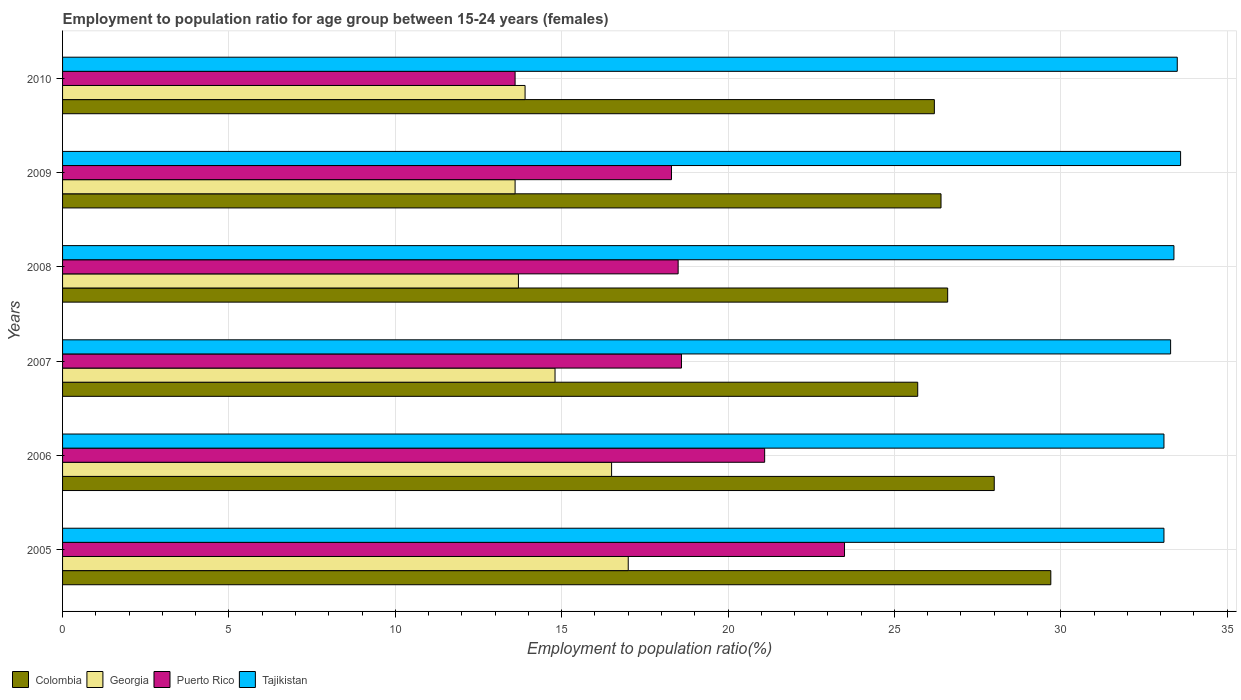How many different coloured bars are there?
Give a very brief answer. 4. How many bars are there on the 6th tick from the top?
Offer a very short reply. 4. How many bars are there on the 4th tick from the bottom?
Your answer should be compact. 4. What is the label of the 5th group of bars from the top?
Provide a short and direct response. 2006. In how many cases, is the number of bars for a given year not equal to the number of legend labels?
Provide a succinct answer. 0. What is the employment to population ratio in Georgia in 2006?
Ensure brevity in your answer.  16.5. Across all years, what is the maximum employment to population ratio in Tajikistan?
Provide a succinct answer. 33.6. Across all years, what is the minimum employment to population ratio in Tajikistan?
Provide a succinct answer. 33.1. In which year was the employment to population ratio in Colombia maximum?
Your answer should be very brief. 2005. In which year was the employment to population ratio in Colombia minimum?
Ensure brevity in your answer.  2007. What is the total employment to population ratio in Colombia in the graph?
Ensure brevity in your answer.  162.6. What is the difference between the employment to population ratio in Puerto Rico in 2009 and the employment to population ratio in Georgia in 2008?
Your answer should be very brief. 4.6. What is the average employment to population ratio in Puerto Rico per year?
Provide a succinct answer. 18.93. In the year 2007, what is the difference between the employment to population ratio in Puerto Rico and employment to population ratio in Georgia?
Offer a very short reply. 3.8. What is the ratio of the employment to population ratio in Georgia in 2006 to that in 2008?
Your answer should be compact. 1.2. Is the difference between the employment to population ratio in Puerto Rico in 2006 and 2008 greater than the difference between the employment to population ratio in Georgia in 2006 and 2008?
Your answer should be compact. No. What is the difference between the highest and the second highest employment to population ratio in Colombia?
Offer a very short reply. 1.7. Is the sum of the employment to population ratio in Puerto Rico in 2007 and 2008 greater than the maximum employment to population ratio in Colombia across all years?
Keep it short and to the point. Yes. Is it the case that in every year, the sum of the employment to population ratio in Tajikistan and employment to population ratio in Colombia is greater than the sum of employment to population ratio in Georgia and employment to population ratio in Puerto Rico?
Provide a succinct answer. Yes. What does the 2nd bar from the bottom in 2005 represents?
Ensure brevity in your answer.  Georgia. How many bars are there?
Your answer should be very brief. 24. Are all the bars in the graph horizontal?
Offer a very short reply. Yes. Where does the legend appear in the graph?
Offer a very short reply. Bottom left. How are the legend labels stacked?
Your response must be concise. Horizontal. What is the title of the graph?
Make the answer very short. Employment to population ratio for age group between 15-24 years (females). What is the label or title of the Y-axis?
Keep it short and to the point. Years. What is the Employment to population ratio(%) of Colombia in 2005?
Provide a short and direct response. 29.7. What is the Employment to population ratio(%) in Puerto Rico in 2005?
Provide a short and direct response. 23.5. What is the Employment to population ratio(%) in Tajikistan in 2005?
Provide a succinct answer. 33.1. What is the Employment to population ratio(%) in Georgia in 2006?
Ensure brevity in your answer.  16.5. What is the Employment to population ratio(%) of Puerto Rico in 2006?
Make the answer very short. 21.1. What is the Employment to population ratio(%) in Tajikistan in 2006?
Keep it short and to the point. 33.1. What is the Employment to population ratio(%) in Colombia in 2007?
Your response must be concise. 25.7. What is the Employment to population ratio(%) of Georgia in 2007?
Your response must be concise. 14.8. What is the Employment to population ratio(%) in Puerto Rico in 2007?
Make the answer very short. 18.6. What is the Employment to population ratio(%) of Tajikistan in 2007?
Keep it short and to the point. 33.3. What is the Employment to population ratio(%) in Colombia in 2008?
Your answer should be very brief. 26.6. What is the Employment to population ratio(%) of Georgia in 2008?
Make the answer very short. 13.7. What is the Employment to population ratio(%) in Tajikistan in 2008?
Provide a short and direct response. 33.4. What is the Employment to population ratio(%) of Colombia in 2009?
Offer a terse response. 26.4. What is the Employment to population ratio(%) of Georgia in 2009?
Ensure brevity in your answer.  13.6. What is the Employment to population ratio(%) of Puerto Rico in 2009?
Give a very brief answer. 18.3. What is the Employment to population ratio(%) in Tajikistan in 2009?
Your answer should be compact. 33.6. What is the Employment to population ratio(%) in Colombia in 2010?
Provide a short and direct response. 26.2. What is the Employment to population ratio(%) of Georgia in 2010?
Your answer should be compact. 13.9. What is the Employment to population ratio(%) of Puerto Rico in 2010?
Offer a terse response. 13.6. What is the Employment to population ratio(%) of Tajikistan in 2010?
Your answer should be very brief. 33.5. Across all years, what is the maximum Employment to population ratio(%) of Colombia?
Give a very brief answer. 29.7. Across all years, what is the maximum Employment to population ratio(%) of Georgia?
Offer a terse response. 17. Across all years, what is the maximum Employment to population ratio(%) in Tajikistan?
Your answer should be very brief. 33.6. Across all years, what is the minimum Employment to population ratio(%) of Colombia?
Provide a succinct answer. 25.7. Across all years, what is the minimum Employment to population ratio(%) of Georgia?
Offer a terse response. 13.6. Across all years, what is the minimum Employment to population ratio(%) in Puerto Rico?
Provide a succinct answer. 13.6. Across all years, what is the minimum Employment to population ratio(%) of Tajikistan?
Offer a terse response. 33.1. What is the total Employment to population ratio(%) in Colombia in the graph?
Your answer should be very brief. 162.6. What is the total Employment to population ratio(%) in Georgia in the graph?
Your answer should be compact. 89.5. What is the total Employment to population ratio(%) in Puerto Rico in the graph?
Your answer should be very brief. 113.6. What is the difference between the Employment to population ratio(%) of Georgia in 2005 and that in 2006?
Make the answer very short. 0.5. What is the difference between the Employment to population ratio(%) in Puerto Rico in 2005 and that in 2007?
Provide a succinct answer. 4.9. What is the difference between the Employment to population ratio(%) in Colombia in 2005 and that in 2008?
Your answer should be compact. 3.1. What is the difference between the Employment to population ratio(%) in Colombia in 2005 and that in 2009?
Provide a short and direct response. 3.3. What is the difference between the Employment to population ratio(%) in Puerto Rico in 2005 and that in 2009?
Your answer should be compact. 5.2. What is the difference between the Employment to population ratio(%) in Tajikistan in 2005 and that in 2009?
Offer a very short reply. -0.5. What is the difference between the Employment to population ratio(%) in Georgia in 2005 and that in 2010?
Provide a short and direct response. 3.1. What is the difference between the Employment to population ratio(%) in Tajikistan in 2005 and that in 2010?
Provide a short and direct response. -0.4. What is the difference between the Employment to population ratio(%) in Georgia in 2006 and that in 2007?
Your answer should be compact. 1.7. What is the difference between the Employment to population ratio(%) in Tajikistan in 2006 and that in 2007?
Give a very brief answer. -0.2. What is the difference between the Employment to population ratio(%) in Puerto Rico in 2006 and that in 2008?
Provide a succinct answer. 2.6. What is the difference between the Employment to population ratio(%) in Tajikistan in 2006 and that in 2008?
Offer a terse response. -0.3. What is the difference between the Employment to population ratio(%) of Colombia in 2006 and that in 2009?
Keep it short and to the point. 1.6. What is the difference between the Employment to population ratio(%) in Georgia in 2006 and that in 2009?
Make the answer very short. 2.9. What is the difference between the Employment to population ratio(%) in Puerto Rico in 2006 and that in 2009?
Provide a succinct answer. 2.8. What is the difference between the Employment to population ratio(%) of Tajikistan in 2006 and that in 2009?
Give a very brief answer. -0.5. What is the difference between the Employment to population ratio(%) of Colombia in 2006 and that in 2010?
Make the answer very short. 1.8. What is the difference between the Employment to population ratio(%) of Puerto Rico in 2006 and that in 2010?
Your answer should be very brief. 7.5. What is the difference between the Employment to population ratio(%) in Tajikistan in 2006 and that in 2010?
Offer a very short reply. -0.4. What is the difference between the Employment to population ratio(%) in Georgia in 2007 and that in 2008?
Your response must be concise. 1.1. What is the difference between the Employment to population ratio(%) of Tajikistan in 2007 and that in 2008?
Your answer should be compact. -0.1. What is the difference between the Employment to population ratio(%) of Colombia in 2007 and that in 2010?
Provide a succinct answer. -0.5. What is the difference between the Employment to population ratio(%) in Tajikistan in 2007 and that in 2010?
Provide a short and direct response. -0.2. What is the difference between the Employment to population ratio(%) in Puerto Rico in 2008 and that in 2009?
Ensure brevity in your answer.  0.2. What is the difference between the Employment to population ratio(%) of Tajikistan in 2008 and that in 2009?
Make the answer very short. -0.2. What is the difference between the Employment to population ratio(%) in Georgia in 2008 and that in 2010?
Make the answer very short. -0.2. What is the difference between the Employment to population ratio(%) in Puerto Rico in 2008 and that in 2010?
Your answer should be very brief. 4.9. What is the difference between the Employment to population ratio(%) of Tajikistan in 2008 and that in 2010?
Offer a very short reply. -0.1. What is the difference between the Employment to population ratio(%) of Georgia in 2009 and that in 2010?
Keep it short and to the point. -0.3. What is the difference between the Employment to population ratio(%) in Tajikistan in 2009 and that in 2010?
Your response must be concise. 0.1. What is the difference between the Employment to population ratio(%) of Colombia in 2005 and the Employment to population ratio(%) of Georgia in 2006?
Offer a very short reply. 13.2. What is the difference between the Employment to population ratio(%) in Colombia in 2005 and the Employment to population ratio(%) in Puerto Rico in 2006?
Ensure brevity in your answer.  8.6. What is the difference between the Employment to population ratio(%) in Georgia in 2005 and the Employment to population ratio(%) in Puerto Rico in 2006?
Keep it short and to the point. -4.1. What is the difference between the Employment to population ratio(%) of Georgia in 2005 and the Employment to population ratio(%) of Tajikistan in 2006?
Your answer should be very brief. -16.1. What is the difference between the Employment to population ratio(%) of Colombia in 2005 and the Employment to population ratio(%) of Puerto Rico in 2007?
Ensure brevity in your answer.  11.1. What is the difference between the Employment to population ratio(%) of Georgia in 2005 and the Employment to population ratio(%) of Puerto Rico in 2007?
Offer a very short reply. -1.6. What is the difference between the Employment to population ratio(%) of Georgia in 2005 and the Employment to population ratio(%) of Tajikistan in 2007?
Your answer should be very brief. -16.3. What is the difference between the Employment to population ratio(%) in Georgia in 2005 and the Employment to population ratio(%) in Puerto Rico in 2008?
Give a very brief answer. -1.5. What is the difference between the Employment to population ratio(%) of Georgia in 2005 and the Employment to population ratio(%) of Tajikistan in 2008?
Ensure brevity in your answer.  -16.4. What is the difference between the Employment to population ratio(%) of Puerto Rico in 2005 and the Employment to population ratio(%) of Tajikistan in 2008?
Keep it short and to the point. -9.9. What is the difference between the Employment to population ratio(%) in Colombia in 2005 and the Employment to population ratio(%) in Puerto Rico in 2009?
Keep it short and to the point. 11.4. What is the difference between the Employment to population ratio(%) in Georgia in 2005 and the Employment to population ratio(%) in Tajikistan in 2009?
Make the answer very short. -16.6. What is the difference between the Employment to population ratio(%) of Colombia in 2005 and the Employment to population ratio(%) of Georgia in 2010?
Offer a terse response. 15.8. What is the difference between the Employment to population ratio(%) of Colombia in 2005 and the Employment to population ratio(%) of Puerto Rico in 2010?
Your response must be concise. 16.1. What is the difference between the Employment to population ratio(%) of Georgia in 2005 and the Employment to population ratio(%) of Tajikistan in 2010?
Make the answer very short. -16.5. What is the difference between the Employment to population ratio(%) in Puerto Rico in 2005 and the Employment to population ratio(%) in Tajikistan in 2010?
Your response must be concise. -10. What is the difference between the Employment to population ratio(%) of Colombia in 2006 and the Employment to population ratio(%) of Georgia in 2007?
Ensure brevity in your answer.  13.2. What is the difference between the Employment to population ratio(%) of Colombia in 2006 and the Employment to population ratio(%) of Tajikistan in 2007?
Give a very brief answer. -5.3. What is the difference between the Employment to population ratio(%) in Georgia in 2006 and the Employment to population ratio(%) in Puerto Rico in 2007?
Your answer should be compact. -2.1. What is the difference between the Employment to population ratio(%) of Georgia in 2006 and the Employment to population ratio(%) of Tajikistan in 2007?
Your answer should be compact. -16.8. What is the difference between the Employment to population ratio(%) in Colombia in 2006 and the Employment to population ratio(%) in Georgia in 2008?
Your answer should be very brief. 14.3. What is the difference between the Employment to population ratio(%) in Georgia in 2006 and the Employment to population ratio(%) in Tajikistan in 2008?
Offer a terse response. -16.9. What is the difference between the Employment to population ratio(%) in Puerto Rico in 2006 and the Employment to population ratio(%) in Tajikistan in 2008?
Ensure brevity in your answer.  -12.3. What is the difference between the Employment to population ratio(%) of Colombia in 2006 and the Employment to population ratio(%) of Georgia in 2009?
Keep it short and to the point. 14.4. What is the difference between the Employment to population ratio(%) of Georgia in 2006 and the Employment to population ratio(%) of Tajikistan in 2009?
Keep it short and to the point. -17.1. What is the difference between the Employment to population ratio(%) of Puerto Rico in 2006 and the Employment to population ratio(%) of Tajikistan in 2009?
Provide a short and direct response. -12.5. What is the difference between the Employment to population ratio(%) of Colombia in 2006 and the Employment to population ratio(%) of Puerto Rico in 2010?
Your response must be concise. 14.4. What is the difference between the Employment to population ratio(%) in Georgia in 2006 and the Employment to population ratio(%) in Puerto Rico in 2010?
Your answer should be very brief. 2.9. What is the difference between the Employment to population ratio(%) in Colombia in 2007 and the Employment to population ratio(%) in Georgia in 2008?
Ensure brevity in your answer.  12. What is the difference between the Employment to population ratio(%) of Georgia in 2007 and the Employment to population ratio(%) of Puerto Rico in 2008?
Keep it short and to the point. -3.7. What is the difference between the Employment to population ratio(%) of Georgia in 2007 and the Employment to population ratio(%) of Tajikistan in 2008?
Your answer should be very brief. -18.6. What is the difference between the Employment to population ratio(%) of Puerto Rico in 2007 and the Employment to population ratio(%) of Tajikistan in 2008?
Keep it short and to the point. -14.8. What is the difference between the Employment to population ratio(%) of Colombia in 2007 and the Employment to population ratio(%) of Georgia in 2009?
Provide a short and direct response. 12.1. What is the difference between the Employment to population ratio(%) in Colombia in 2007 and the Employment to population ratio(%) in Tajikistan in 2009?
Your response must be concise. -7.9. What is the difference between the Employment to population ratio(%) in Georgia in 2007 and the Employment to population ratio(%) in Puerto Rico in 2009?
Offer a terse response. -3.5. What is the difference between the Employment to population ratio(%) of Georgia in 2007 and the Employment to population ratio(%) of Tajikistan in 2009?
Give a very brief answer. -18.8. What is the difference between the Employment to population ratio(%) of Colombia in 2007 and the Employment to population ratio(%) of Georgia in 2010?
Your answer should be very brief. 11.8. What is the difference between the Employment to population ratio(%) in Georgia in 2007 and the Employment to population ratio(%) in Tajikistan in 2010?
Keep it short and to the point. -18.7. What is the difference between the Employment to population ratio(%) of Puerto Rico in 2007 and the Employment to population ratio(%) of Tajikistan in 2010?
Provide a short and direct response. -14.9. What is the difference between the Employment to population ratio(%) in Colombia in 2008 and the Employment to population ratio(%) in Georgia in 2009?
Your answer should be compact. 13. What is the difference between the Employment to population ratio(%) in Colombia in 2008 and the Employment to population ratio(%) in Puerto Rico in 2009?
Your response must be concise. 8.3. What is the difference between the Employment to population ratio(%) in Georgia in 2008 and the Employment to population ratio(%) in Tajikistan in 2009?
Make the answer very short. -19.9. What is the difference between the Employment to population ratio(%) in Puerto Rico in 2008 and the Employment to population ratio(%) in Tajikistan in 2009?
Give a very brief answer. -15.1. What is the difference between the Employment to population ratio(%) in Colombia in 2008 and the Employment to population ratio(%) in Tajikistan in 2010?
Offer a terse response. -6.9. What is the difference between the Employment to population ratio(%) of Georgia in 2008 and the Employment to population ratio(%) of Tajikistan in 2010?
Provide a succinct answer. -19.8. What is the difference between the Employment to population ratio(%) in Puerto Rico in 2008 and the Employment to population ratio(%) in Tajikistan in 2010?
Provide a succinct answer. -15. What is the difference between the Employment to population ratio(%) of Colombia in 2009 and the Employment to population ratio(%) of Georgia in 2010?
Make the answer very short. 12.5. What is the difference between the Employment to population ratio(%) of Colombia in 2009 and the Employment to population ratio(%) of Tajikistan in 2010?
Ensure brevity in your answer.  -7.1. What is the difference between the Employment to population ratio(%) in Georgia in 2009 and the Employment to population ratio(%) in Tajikistan in 2010?
Your response must be concise. -19.9. What is the difference between the Employment to population ratio(%) in Puerto Rico in 2009 and the Employment to population ratio(%) in Tajikistan in 2010?
Your answer should be very brief. -15.2. What is the average Employment to population ratio(%) in Colombia per year?
Give a very brief answer. 27.1. What is the average Employment to population ratio(%) in Georgia per year?
Your answer should be very brief. 14.92. What is the average Employment to population ratio(%) in Puerto Rico per year?
Provide a short and direct response. 18.93. What is the average Employment to population ratio(%) of Tajikistan per year?
Offer a terse response. 33.33. In the year 2005, what is the difference between the Employment to population ratio(%) of Colombia and Employment to population ratio(%) of Puerto Rico?
Your response must be concise. 6.2. In the year 2005, what is the difference between the Employment to population ratio(%) in Colombia and Employment to population ratio(%) in Tajikistan?
Offer a very short reply. -3.4. In the year 2005, what is the difference between the Employment to population ratio(%) in Georgia and Employment to population ratio(%) in Puerto Rico?
Your answer should be compact. -6.5. In the year 2005, what is the difference between the Employment to population ratio(%) in Georgia and Employment to population ratio(%) in Tajikistan?
Ensure brevity in your answer.  -16.1. In the year 2006, what is the difference between the Employment to population ratio(%) of Colombia and Employment to population ratio(%) of Puerto Rico?
Ensure brevity in your answer.  6.9. In the year 2006, what is the difference between the Employment to population ratio(%) of Colombia and Employment to population ratio(%) of Tajikistan?
Your answer should be very brief. -5.1. In the year 2006, what is the difference between the Employment to population ratio(%) in Georgia and Employment to population ratio(%) in Tajikistan?
Provide a short and direct response. -16.6. In the year 2007, what is the difference between the Employment to population ratio(%) of Colombia and Employment to population ratio(%) of Puerto Rico?
Your answer should be compact. 7.1. In the year 2007, what is the difference between the Employment to population ratio(%) of Colombia and Employment to population ratio(%) of Tajikistan?
Ensure brevity in your answer.  -7.6. In the year 2007, what is the difference between the Employment to population ratio(%) of Georgia and Employment to population ratio(%) of Puerto Rico?
Provide a short and direct response. -3.8. In the year 2007, what is the difference between the Employment to population ratio(%) of Georgia and Employment to population ratio(%) of Tajikistan?
Give a very brief answer. -18.5. In the year 2007, what is the difference between the Employment to population ratio(%) in Puerto Rico and Employment to population ratio(%) in Tajikistan?
Your response must be concise. -14.7. In the year 2008, what is the difference between the Employment to population ratio(%) of Colombia and Employment to population ratio(%) of Puerto Rico?
Offer a very short reply. 8.1. In the year 2008, what is the difference between the Employment to population ratio(%) in Colombia and Employment to population ratio(%) in Tajikistan?
Make the answer very short. -6.8. In the year 2008, what is the difference between the Employment to population ratio(%) in Georgia and Employment to population ratio(%) in Tajikistan?
Your answer should be very brief. -19.7. In the year 2008, what is the difference between the Employment to population ratio(%) of Puerto Rico and Employment to population ratio(%) of Tajikistan?
Provide a succinct answer. -14.9. In the year 2009, what is the difference between the Employment to population ratio(%) of Colombia and Employment to population ratio(%) of Puerto Rico?
Keep it short and to the point. 8.1. In the year 2009, what is the difference between the Employment to population ratio(%) in Georgia and Employment to population ratio(%) in Puerto Rico?
Ensure brevity in your answer.  -4.7. In the year 2009, what is the difference between the Employment to population ratio(%) of Puerto Rico and Employment to population ratio(%) of Tajikistan?
Your answer should be very brief. -15.3. In the year 2010, what is the difference between the Employment to population ratio(%) of Colombia and Employment to population ratio(%) of Georgia?
Your answer should be very brief. 12.3. In the year 2010, what is the difference between the Employment to population ratio(%) in Georgia and Employment to population ratio(%) in Tajikistan?
Offer a very short reply. -19.6. In the year 2010, what is the difference between the Employment to population ratio(%) of Puerto Rico and Employment to population ratio(%) of Tajikistan?
Offer a terse response. -19.9. What is the ratio of the Employment to population ratio(%) in Colombia in 2005 to that in 2006?
Provide a short and direct response. 1.06. What is the ratio of the Employment to population ratio(%) of Georgia in 2005 to that in 2006?
Provide a succinct answer. 1.03. What is the ratio of the Employment to population ratio(%) of Puerto Rico in 2005 to that in 2006?
Keep it short and to the point. 1.11. What is the ratio of the Employment to population ratio(%) in Tajikistan in 2005 to that in 2006?
Your response must be concise. 1. What is the ratio of the Employment to population ratio(%) of Colombia in 2005 to that in 2007?
Keep it short and to the point. 1.16. What is the ratio of the Employment to population ratio(%) in Georgia in 2005 to that in 2007?
Your answer should be compact. 1.15. What is the ratio of the Employment to population ratio(%) of Puerto Rico in 2005 to that in 2007?
Offer a very short reply. 1.26. What is the ratio of the Employment to population ratio(%) of Tajikistan in 2005 to that in 2007?
Your response must be concise. 0.99. What is the ratio of the Employment to population ratio(%) of Colombia in 2005 to that in 2008?
Your answer should be very brief. 1.12. What is the ratio of the Employment to population ratio(%) of Georgia in 2005 to that in 2008?
Make the answer very short. 1.24. What is the ratio of the Employment to population ratio(%) of Puerto Rico in 2005 to that in 2008?
Your answer should be compact. 1.27. What is the ratio of the Employment to population ratio(%) of Tajikistan in 2005 to that in 2008?
Provide a short and direct response. 0.99. What is the ratio of the Employment to population ratio(%) of Puerto Rico in 2005 to that in 2009?
Offer a very short reply. 1.28. What is the ratio of the Employment to population ratio(%) of Tajikistan in 2005 to that in 2009?
Your answer should be very brief. 0.99. What is the ratio of the Employment to population ratio(%) in Colombia in 2005 to that in 2010?
Your answer should be very brief. 1.13. What is the ratio of the Employment to population ratio(%) in Georgia in 2005 to that in 2010?
Offer a very short reply. 1.22. What is the ratio of the Employment to population ratio(%) in Puerto Rico in 2005 to that in 2010?
Offer a very short reply. 1.73. What is the ratio of the Employment to population ratio(%) in Colombia in 2006 to that in 2007?
Keep it short and to the point. 1.09. What is the ratio of the Employment to population ratio(%) of Georgia in 2006 to that in 2007?
Give a very brief answer. 1.11. What is the ratio of the Employment to population ratio(%) of Puerto Rico in 2006 to that in 2007?
Offer a terse response. 1.13. What is the ratio of the Employment to population ratio(%) in Tajikistan in 2006 to that in 2007?
Ensure brevity in your answer.  0.99. What is the ratio of the Employment to population ratio(%) in Colombia in 2006 to that in 2008?
Ensure brevity in your answer.  1.05. What is the ratio of the Employment to population ratio(%) of Georgia in 2006 to that in 2008?
Offer a very short reply. 1.2. What is the ratio of the Employment to population ratio(%) of Puerto Rico in 2006 to that in 2008?
Your response must be concise. 1.14. What is the ratio of the Employment to population ratio(%) in Colombia in 2006 to that in 2009?
Keep it short and to the point. 1.06. What is the ratio of the Employment to population ratio(%) in Georgia in 2006 to that in 2009?
Your response must be concise. 1.21. What is the ratio of the Employment to population ratio(%) of Puerto Rico in 2006 to that in 2009?
Your answer should be very brief. 1.15. What is the ratio of the Employment to population ratio(%) in Tajikistan in 2006 to that in 2009?
Provide a short and direct response. 0.99. What is the ratio of the Employment to population ratio(%) in Colombia in 2006 to that in 2010?
Provide a short and direct response. 1.07. What is the ratio of the Employment to population ratio(%) in Georgia in 2006 to that in 2010?
Your response must be concise. 1.19. What is the ratio of the Employment to population ratio(%) in Puerto Rico in 2006 to that in 2010?
Ensure brevity in your answer.  1.55. What is the ratio of the Employment to population ratio(%) in Colombia in 2007 to that in 2008?
Keep it short and to the point. 0.97. What is the ratio of the Employment to population ratio(%) of Georgia in 2007 to that in 2008?
Give a very brief answer. 1.08. What is the ratio of the Employment to population ratio(%) of Puerto Rico in 2007 to that in 2008?
Offer a terse response. 1.01. What is the ratio of the Employment to population ratio(%) of Tajikistan in 2007 to that in 2008?
Give a very brief answer. 1. What is the ratio of the Employment to population ratio(%) of Colombia in 2007 to that in 2009?
Your answer should be very brief. 0.97. What is the ratio of the Employment to population ratio(%) of Georgia in 2007 to that in 2009?
Ensure brevity in your answer.  1.09. What is the ratio of the Employment to population ratio(%) in Puerto Rico in 2007 to that in 2009?
Make the answer very short. 1.02. What is the ratio of the Employment to population ratio(%) in Colombia in 2007 to that in 2010?
Offer a terse response. 0.98. What is the ratio of the Employment to population ratio(%) of Georgia in 2007 to that in 2010?
Provide a short and direct response. 1.06. What is the ratio of the Employment to population ratio(%) in Puerto Rico in 2007 to that in 2010?
Provide a short and direct response. 1.37. What is the ratio of the Employment to population ratio(%) in Colombia in 2008 to that in 2009?
Keep it short and to the point. 1.01. What is the ratio of the Employment to population ratio(%) in Georgia in 2008 to that in 2009?
Ensure brevity in your answer.  1.01. What is the ratio of the Employment to population ratio(%) of Puerto Rico in 2008 to that in 2009?
Provide a succinct answer. 1.01. What is the ratio of the Employment to population ratio(%) in Tajikistan in 2008 to that in 2009?
Offer a terse response. 0.99. What is the ratio of the Employment to population ratio(%) in Colombia in 2008 to that in 2010?
Offer a terse response. 1.02. What is the ratio of the Employment to population ratio(%) of Georgia in 2008 to that in 2010?
Keep it short and to the point. 0.99. What is the ratio of the Employment to population ratio(%) in Puerto Rico in 2008 to that in 2010?
Provide a succinct answer. 1.36. What is the ratio of the Employment to population ratio(%) of Tajikistan in 2008 to that in 2010?
Ensure brevity in your answer.  1. What is the ratio of the Employment to population ratio(%) in Colombia in 2009 to that in 2010?
Your answer should be compact. 1.01. What is the ratio of the Employment to population ratio(%) in Georgia in 2009 to that in 2010?
Make the answer very short. 0.98. What is the ratio of the Employment to population ratio(%) of Puerto Rico in 2009 to that in 2010?
Your answer should be very brief. 1.35. What is the ratio of the Employment to population ratio(%) of Tajikistan in 2009 to that in 2010?
Provide a succinct answer. 1. What is the difference between the highest and the second highest Employment to population ratio(%) of Colombia?
Your answer should be compact. 1.7. What is the difference between the highest and the second highest Employment to population ratio(%) in Tajikistan?
Offer a very short reply. 0.1. What is the difference between the highest and the lowest Employment to population ratio(%) in Colombia?
Offer a terse response. 4. What is the difference between the highest and the lowest Employment to population ratio(%) in Puerto Rico?
Your answer should be compact. 9.9. 